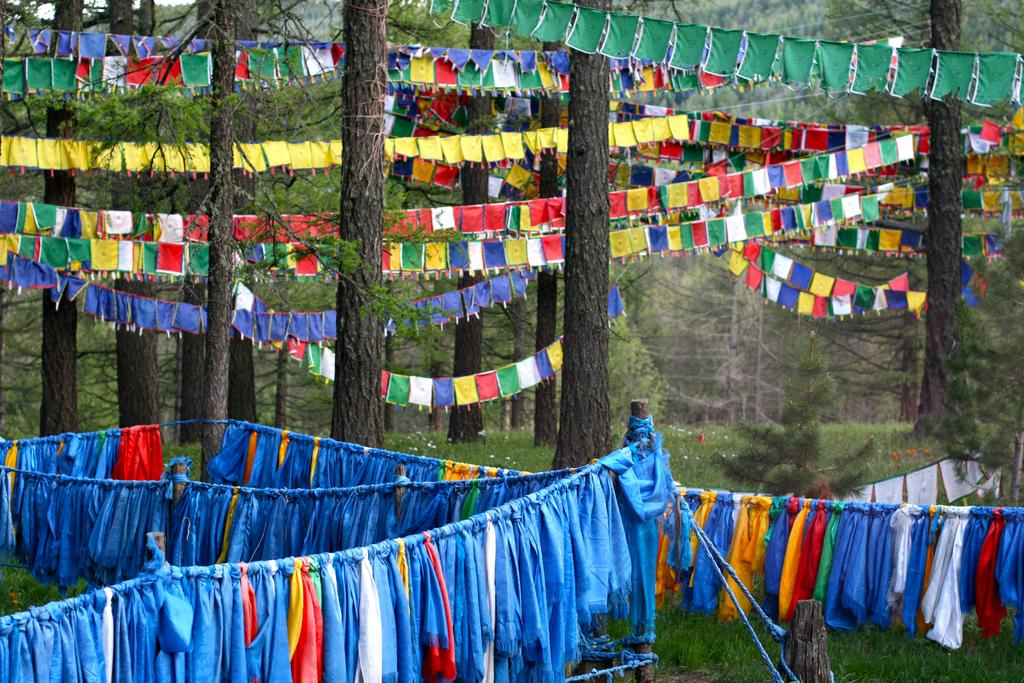What type of vegetation is present in the image? There are trees in the image. What else can be seen flying in the image? There are flags in the image. What is the ground covered with in the image? There is grass in the image. What objects are used to hang or support something in the image? There are ropes in the image. What items are being hung or displayed in the image? There are clothes in the image. How many brothers are playing with a tent in the image? There is no mention of brothers or a tent in the image; it features trees, flags, grass, ropes, and clothes. 